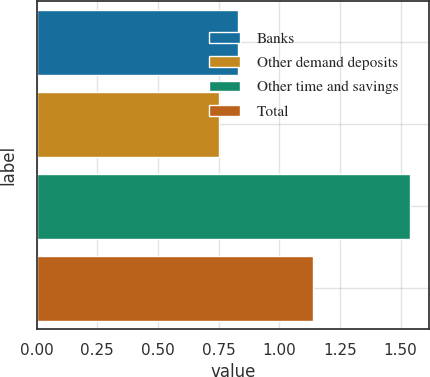Convert chart. <chart><loc_0><loc_0><loc_500><loc_500><bar_chart><fcel>Banks<fcel>Other demand deposits<fcel>Other time and savings<fcel>Total<nl><fcel>0.83<fcel>0.75<fcel>1.54<fcel>1.14<nl></chart> 